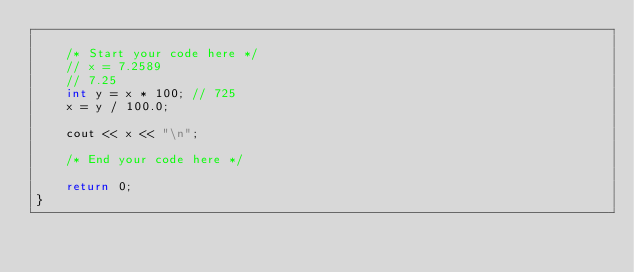Convert code to text. <code><loc_0><loc_0><loc_500><loc_500><_C++_>
	/* Start your code here */
	// x = 7.2589
	// 7.25
	int y = x * 100; // 725
	x = y / 100.0;

	cout << x << "\n";

	/* End your code here */

	return 0;
}
</code> 